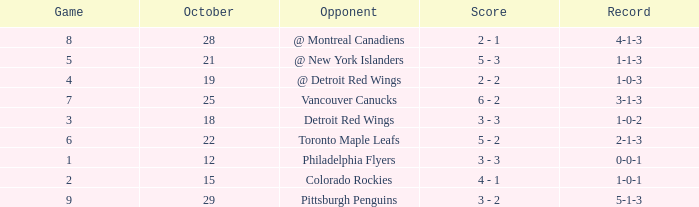Name the most october for game less than 1 None. 